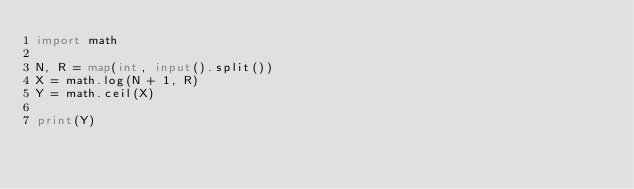Convert code to text. <code><loc_0><loc_0><loc_500><loc_500><_Python_>import math

N, R = map(int, input().split())
X = math.log(N + 1, R)
Y = math.ceil(X)

print(Y)</code> 